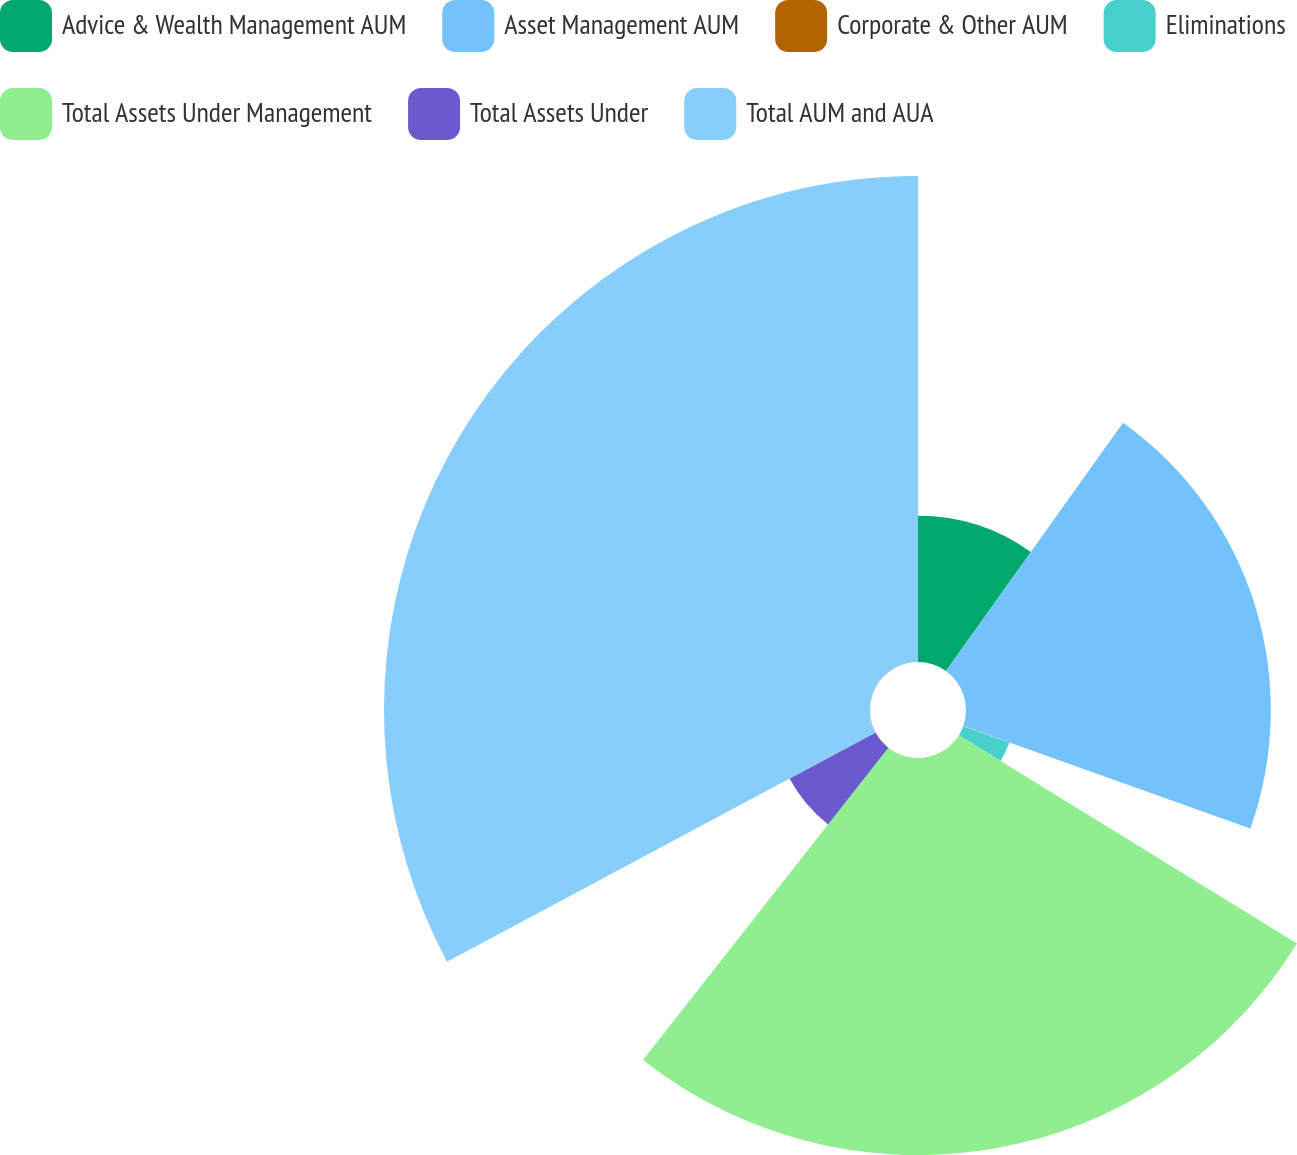Convert chart to OTSL. <chart><loc_0><loc_0><loc_500><loc_500><pie_chart><fcel>Advice & Wealth Management AUM<fcel>Asset Management AUM<fcel>Corporate & Other AUM<fcel>Eliminations<fcel>Total Assets Under Management<fcel>Total Assets Under<fcel>Total AUM and AUA<nl><fcel>9.87%<fcel>20.58%<fcel>0.03%<fcel>3.31%<fcel>26.81%<fcel>6.59%<fcel>32.81%<nl></chart> 